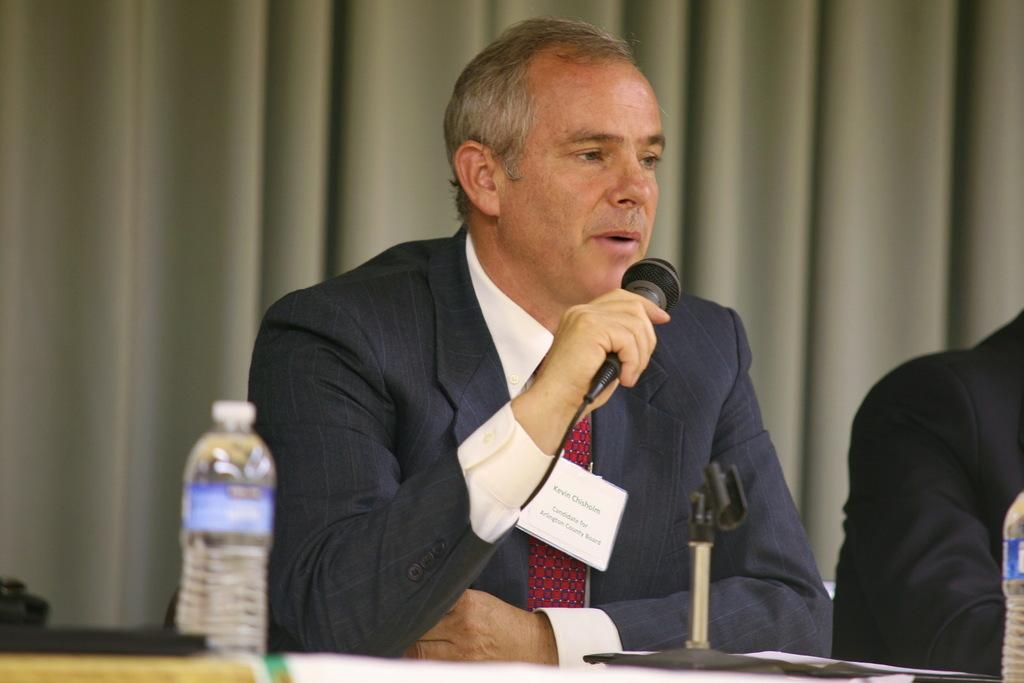What is the main subject of the image? There is a person in the image. What is the person holding in the image? The person is holding a microphone and a water bottle. What type of invention is the person using to measure the growth of the finger in the image? There is no invention, finger, or growth measurement present in the image. 